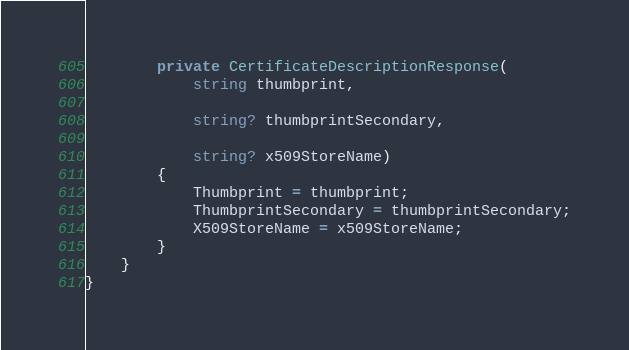<code> <loc_0><loc_0><loc_500><loc_500><_C#_>        private CertificateDescriptionResponse(
            string thumbprint,

            string? thumbprintSecondary,

            string? x509StoreName)
        {
            Thumbprint = thumbprint;
            ThumbprintSecondary = thumbprintSecondary;
            X509StoreName = x509StoreName;
        }
    }
}
</code> 